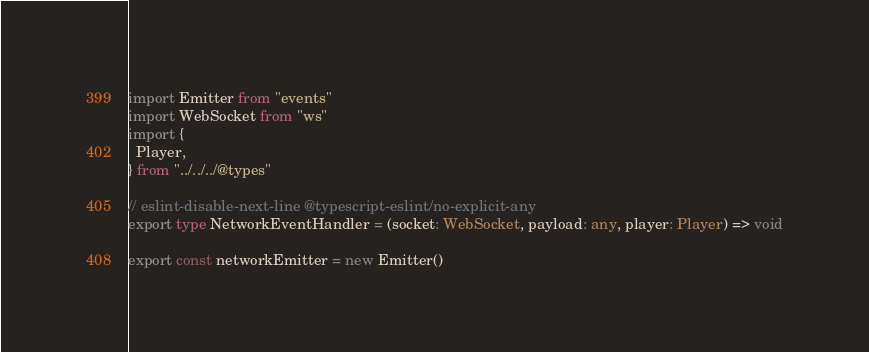<code> <loc_0><loc_0><loc_500><loc_500><_TypeScript_>import Emitter from "events"
import WebSocket from "ws"
import {
  Player, 
} from "../../../@types"

// eslint-disable-next-line @typescript-eslint/no-explicit-any
export type NetworkEventHandler = (socket: WebSocket, payload: any, player: Player) => void

export const networkEmitter = new Emitter()
</code> 